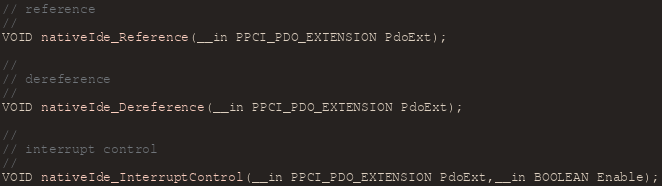<code> <loc_0><loc_0><loc_500><loc_500><_C_>// reference
//
VOID nativeIde_Reference(__in PPCI_PDO_EXTENSION PdoExt);

//
// dereference
//
VOID nativeIde_Dereference(__in PPCI_PDO_EXTENSION PdoExt);

//
// interrupt control
//
VOID nativeIde_InterruptControl(__in PPCI_PDO_EXTENSION PdoExt,__in BOOLEAN Enable);</code> 